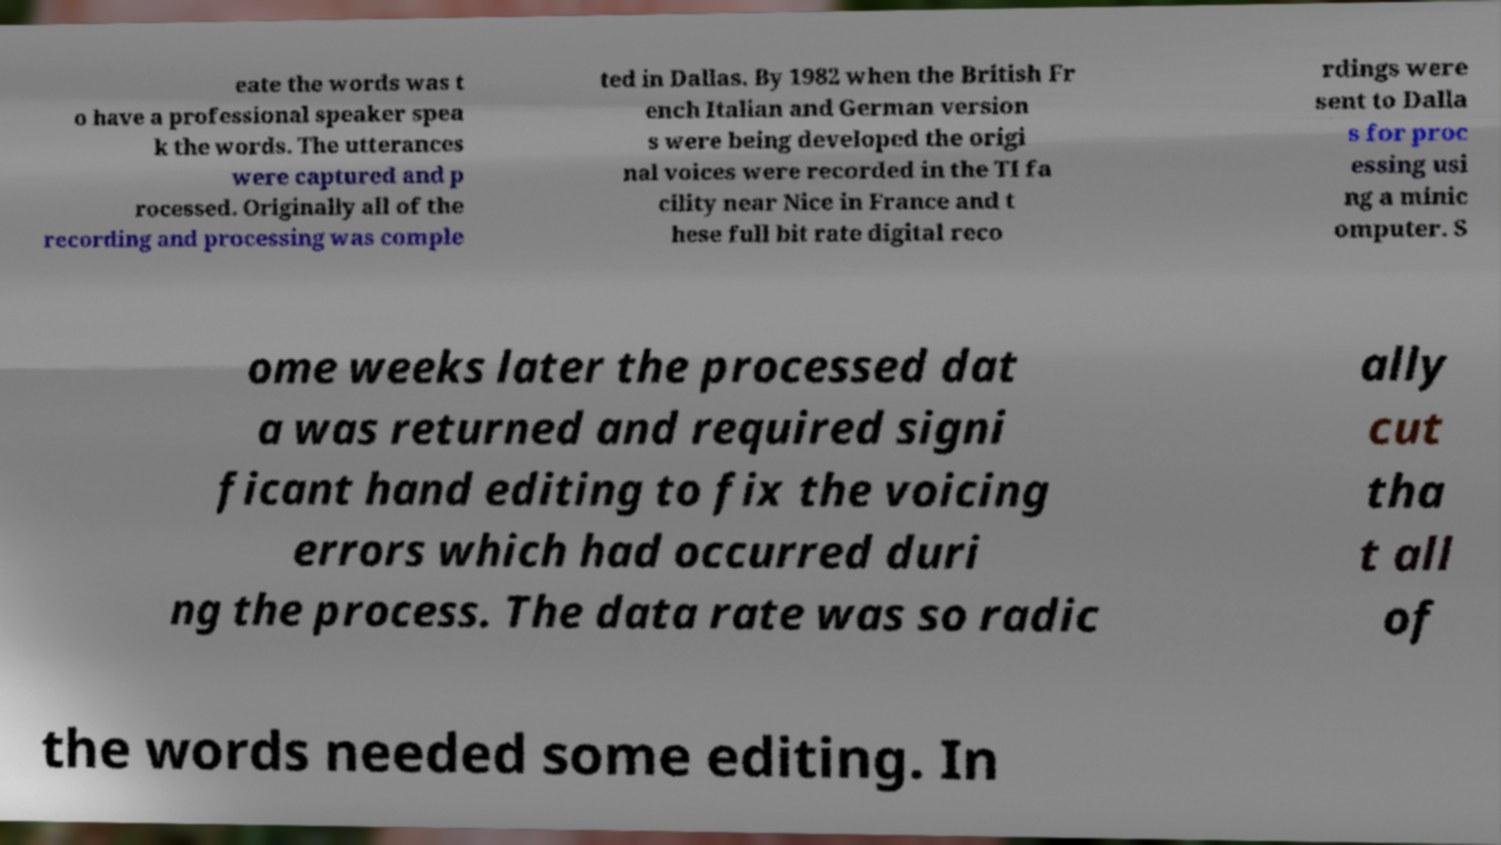Could you assist in decoding the text presented in this image and type it out clearly? eate the words was t o have a professional speaker spea k the words. The utterances were captured and p rocessed. Originally all of the recording and processing was comple ted in Dallas. By 1982 when the British Fr ench Italian and German version s were being developed the origi nal voices were recorded in the TI fa cility near Nice in France and t hese full bit rate digital reco rdings were sent to Dalla s for proc essing usi ng a minic omputer. S ome weeks later the processed dat a was returned and required signi ficant hand editing to fix the voicing errors which had occurred duri ng the process. The data rate was so radic ally cut tha t all of the words needed some editing. In 